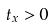<formula> <loc_0><loc_0><loc_500><loc_500>t _ { x } > 0</formula> 